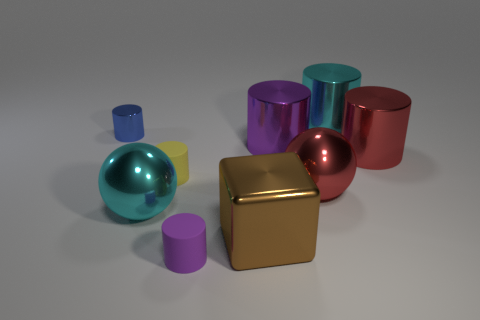Subtract all purple cylinders. How many cylinders are left? 4 Subtract all cyan spheres. How many spheres are left? 1 Subtract 3 cylinders. How many cylinders are left? 3 Subtract all purple blocks. How many purple cylinders are left? 2 Subtract all balls. How many objects are left? 7 Add 3 small red blocks. How many small red blocks exist? 3 Subtract 0 purple cubes. How many objects are left? 9 Subtract all brown balls. Subtract all purple cubes. How many balls are left? 2 Subtract all large red objects. Subtract all tiny shiny cylinders. How many objects are left? 6 Add 6 small purple cylinders. How many small purple cylinders are left? 7 